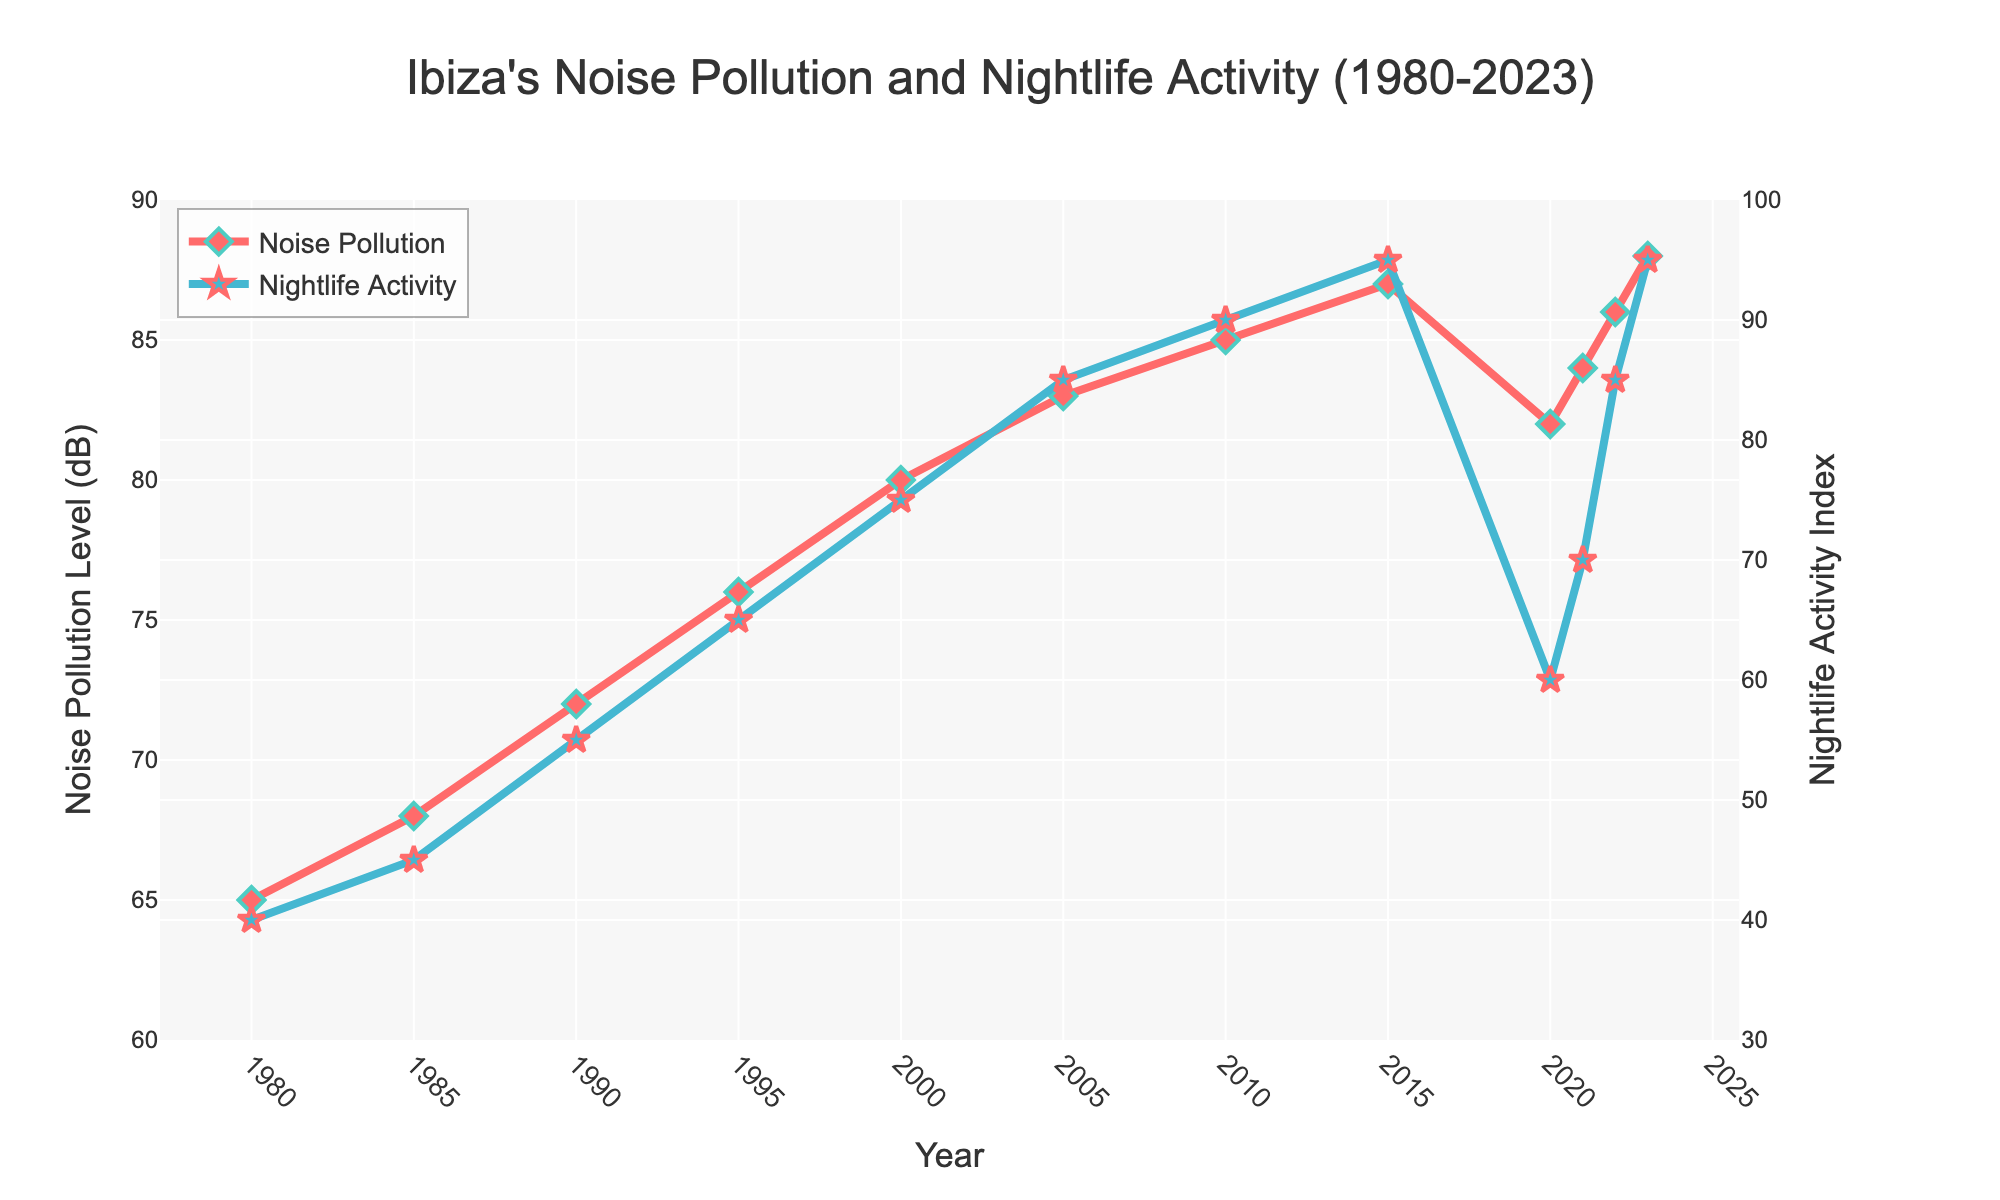What's the highest level of noise pollution recorded throughout the years? The highest level of noise pollution can be determined by identifying the maximum value on the Noise Pollution Level (dB) axis of the chart. The highest point on the red line corresponds to 88 dB in the year 2023.
Answer: 88 dB How did the nightlife activity index change from 2020 to 2023? To determine the change, we look at the values of the Nightlife Activity Index at 2020 and 2023. In 2020, the index was 60, and by 2023, it increased to 95. The change is 95 - 60 = 35.
Answer: Increased by 35 What's the average noise pollution level between 1980 and 2000? The noise pollution levels from 1980 to 2000 are 65, 68, 72, 76, and 80. Summing these values: 65 + 68 + 72 + 76 + 80 = 361. The average is 361 / 5.
Answer: 72.2 dB Which year had a higher nightlife activity index, 2010 or 2022? By comparing the nightlife activity indexes for the years 2010 and 2022, we see that in 2010, the index was 90, and in 2022, it was 85.
Answer: 2010 What is the overall trend of noise pollution levels from 1980 to 2023? By observing the red line representing noise pollution levels, it generally shows an upward trend from 1980 to 2023, despite minor fluctuations.
Answer: Upward trend Compare the noise pollution level and nightlife activity index in 1995. In 1995, the noise pollution level was 76 dB, and the nightlife activity index was 65. Both values can be directly crosschecked in the figure.
Answer: 76 dB and 65 How much did the noise pollution level increase from 1980 to 2015? The noise pollution level in 1980 was 65 dB, and in 2015, it was 87 dB. The increase is calculated as 87 - 65 = 22.
Answer: Increased by 22 dB Explain how noise pollution and nightlife activity correlate in 2023. In 2023, the high value for both noise pollution and nightlife activity suggests a strong positive correlation, implying that increased nightlife activity is associated with higher noise pollution levels.
Answer: Strong positive correlation 